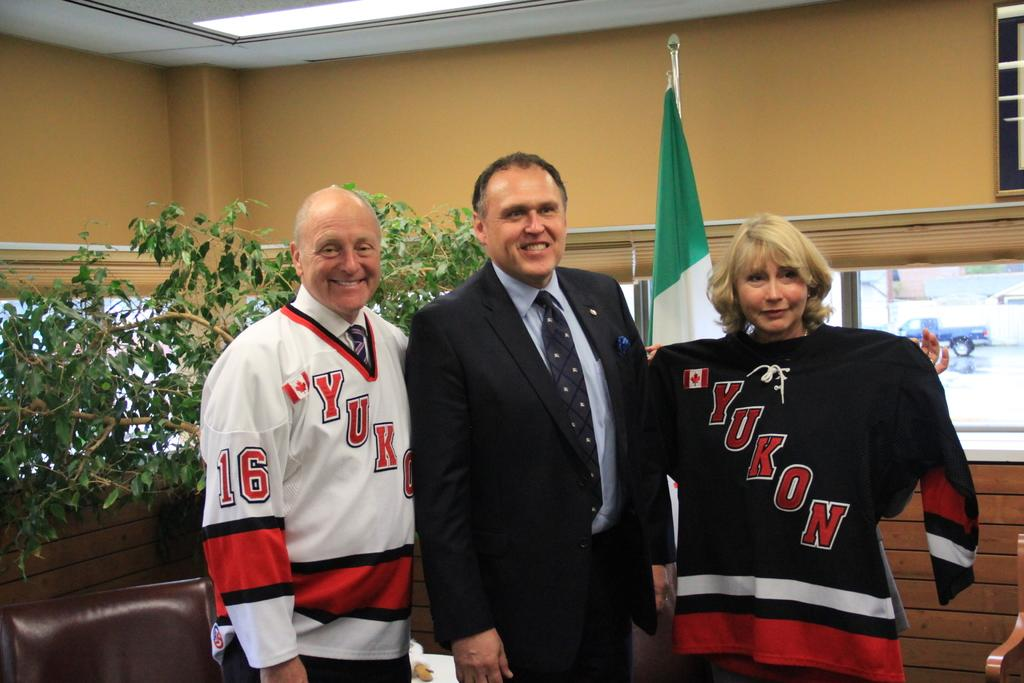<image>
Create a compact narrative representing the image presented. The people posing for a picture must be big Yukon fans. 